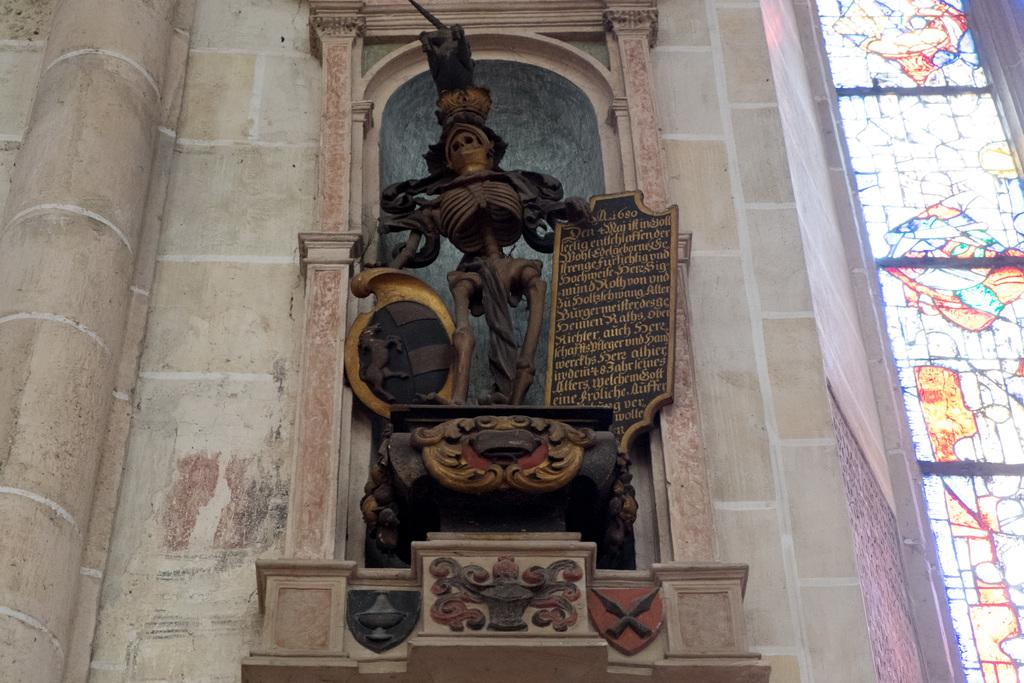What is the main subject in the center of the image? There is a statue in the center of the image. What can be seen in the background of the image? There is a wall in the background of the image. What hobbies does the statue have in the image? The statue is an inanimate object and does not have hobbies. 